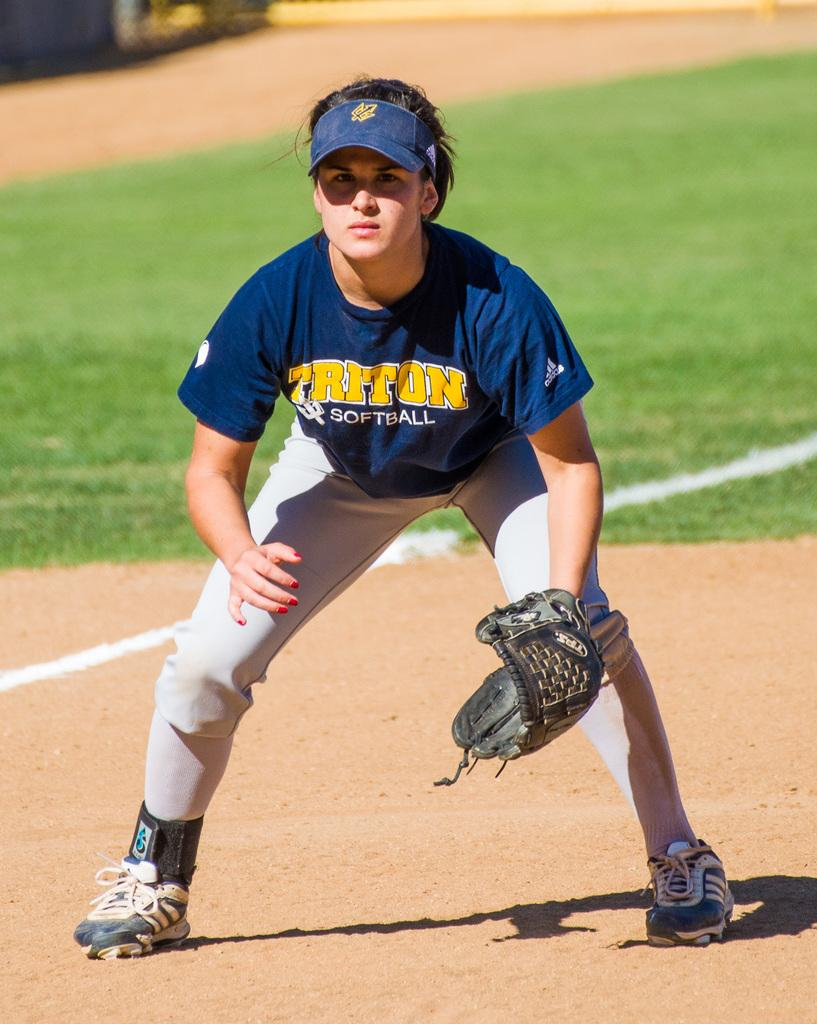Provide a one-sentence caption for the provided image. A female Triton softball player leans over on the field awaiting the next play. 